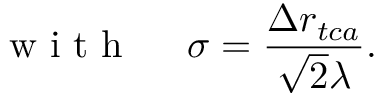<formula> <loc_0><loc_0><loc_500><loc_500>w i t h \quad \sigma = \frac { \Delta r _ { t c a } } { \sqrt { 2 } \lambda } .</formula> 